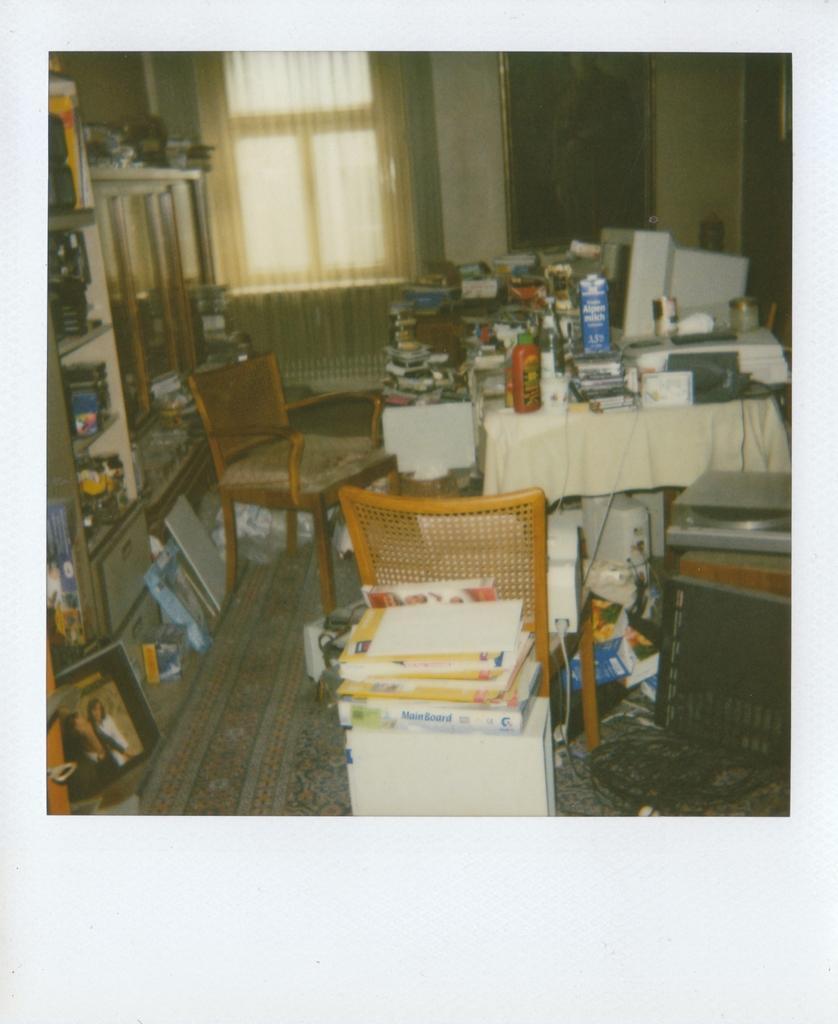Could you give a brief overview of what you see in this image? This image consists of a photograph. This is an inside view of a room. On the right side there is a table which is covered with a cloth. On the table few bottles, monitor, books and many other objects are placed. At the bottom there is a chair on which few devices are placed. Behind the chair there are few books. An the left side there is a rack which is filled with many objects. At the bottom there are few objects placed on the floor. In the background there is a curtain to the window and also I can see a frame is attached to the wall. 